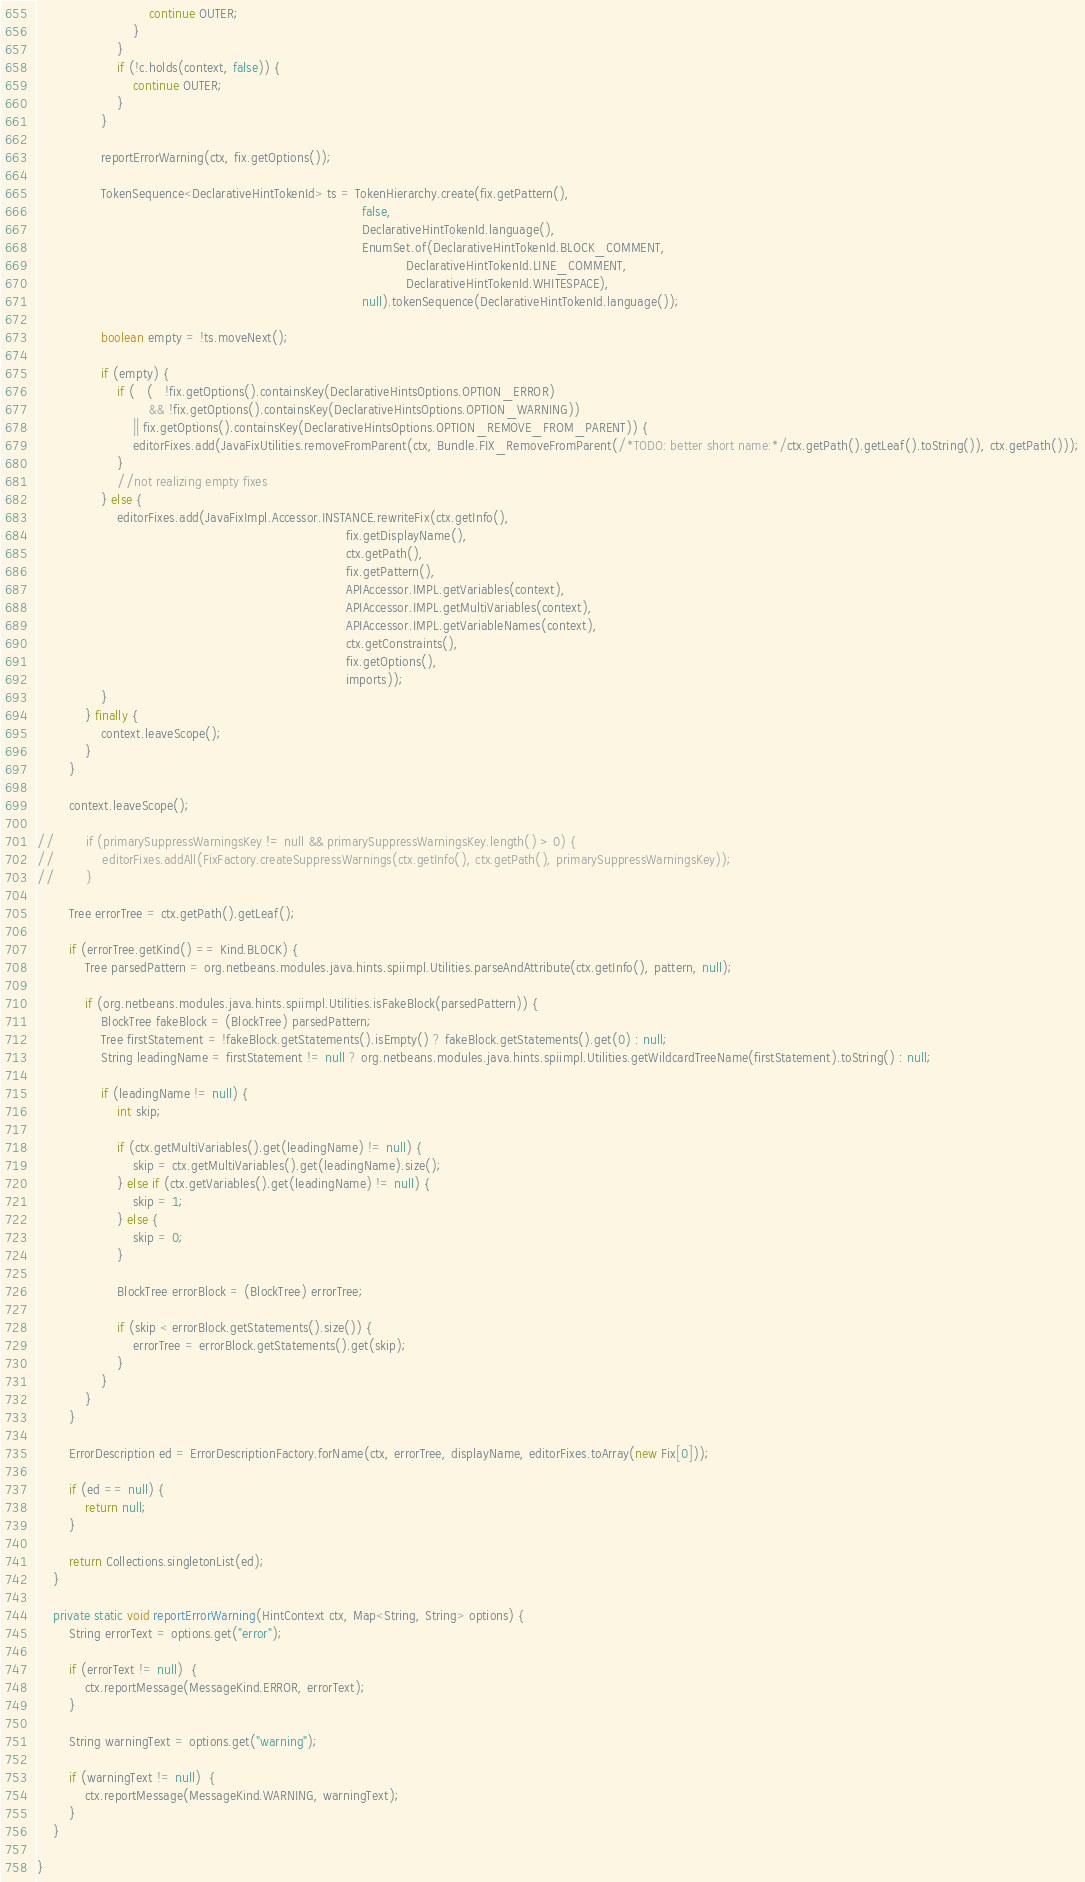<code> <loc_0><loc_0><loc_500><loc_500><_Java_>                            continue OUTER;
                        }
                    }
                    if (!c.holds(context, false)) {
                        continue OUTER;
                    }
                }

                reportErrorWarning(ctx, fix.getOptions());

                TokenSequence<DeclarativeHintTokenId> ts = TokenHierarchy.create(fix.getPattern(),
                                                                                 false,
                                                                                 DeclarativeHintTokenId.language(),
                                                                                 EnumSet.of(DeclarativeHintTokenId.BLOCK_COMMENT,
                                                                                            DeclarativeHintTokenId.LINE_COMMENT,
                                                                                            DeclarativeHintTokenId.WHITESPACE),
                                                                                 null).tokenSequence(DeclarativeHintTokenId.language());

                boolean empty = !ts.moveNext();

                if (empty) {
                    if (   (   !fix.getOptions().containsKey(DeclarativeHintsOptions.OPTION_ERROR)
                            && !fix.getOptions().containsKey(DeclarativeHintsOptions.OPTION_WARNING))
                        || fix.getOptions().containsKey(DeclarativeHintsOptions.OPTION_REMOVE_FROM_PARENT)) {
                        editorFixes.add(JavaFixUtilities.removeFromParent(ctx, Bundle.FIX_RemoveFromParent(/*TODO: better short name:*/ctx.getPath().getLeaf().toString()), ctx.getPath()));
                    }
                    //not realizing empty fixes
                } else {
                    editorFixes.add(JavaFixImpl.Accessor.INSTANCE.rewriteFix(ctx.getInfo(),
                                                                             fix.getDisplayName(),
                                                                             ctx.getPath(),
                                                                             fix.getPattern(),
                                                                             APIAccessor.IMPL.getVariables(context),
                                                                             APIAccessor.IMPL.getMultiVariables(context),
                                                                             APIAccessor.IMPL.getVariableNames(context),
                                                                             ctx.getConstraints(),
                                                                             fix.getOptions(),
                                                                             imports));
                }
            } finally {
                context.leaveScope();
            }
        }

        context.leaveScope();

//        if (primarySuppressWarningsKey != null && primarySuppressWarningsKey.length() > 0) {
//            editorFixes.addAll(FixFactory.createSuppressWarnings(ctx.getInfo(), ctx.getPath(), primarySuppressWarningsKey));
//        }

        Tree errorTree = ctx.getPath().getLeaf();
        
        if (errorTree.getKind() == Kind.BLOCK) {
            Tree parsedPattern = org.netbeans.modules.java.hints.spiimpl.Utilities.parseAndAttribute(ctx.getInfo(), pattern, null);
            
            if (org.netbeans.modules.java.hints.spiimpl.Utilities.isFakeBlock(parsedPattern)) {
                BlockTree fakeBlock = (BlockTree) parsedPattern;
                Tree firstStatement = !fakeBlock.getStatements().isEmpty() ? fakeBlock.getStatements().get(0) : null;
                String leadingName = firstStatement != null ? org.netbeans.modules.java.hints.spiimpl.Utilities.getWildcardTreeName(firstStatement).toString() : null;
                
                if (leadingName != null) {
                    int skip;
                    
                    if (ctx.getMultiVariables().get(leadingName) != null) {
                        skip = ctx.getMultiVariables().get(leadingName).size();
                    } else if (ctx.getVariables().get(leadingName) != null) {
                        skip = 1;
                    } else {
                        skip = 0;
                    }
                    
                    BlockTree errorBlock = (BlockTree) errorTree;

                    if (skip < errorBlock.getStatements().size()) {
                        errorTree = errorBlock.getStatements().get(skip);
                    }
                }
            }
        }
        
        ErrorDescription ed = ErrorDescriptionFactory.forName(ctx, errorTree, displayName, editorFixes.toArray(new Fix[0]));

        if (ed == null) {
            return null;
        }

        return Collections.singletonList(ed);
    }

    private static void reportErrorWarning(HintContext ctx, Map<String, String> options) {
        String errorText = options.get("error");

        if (errorText != null)  {
            ctx.reportMessage(MessageKind.ERROR, errorText);
        }

        String warningText = options.get("warning");

        if (warningText != null)  {
            ctx.reportMessage(MessageKind.WARNING, warningText);
        }
    }

}
</code> 